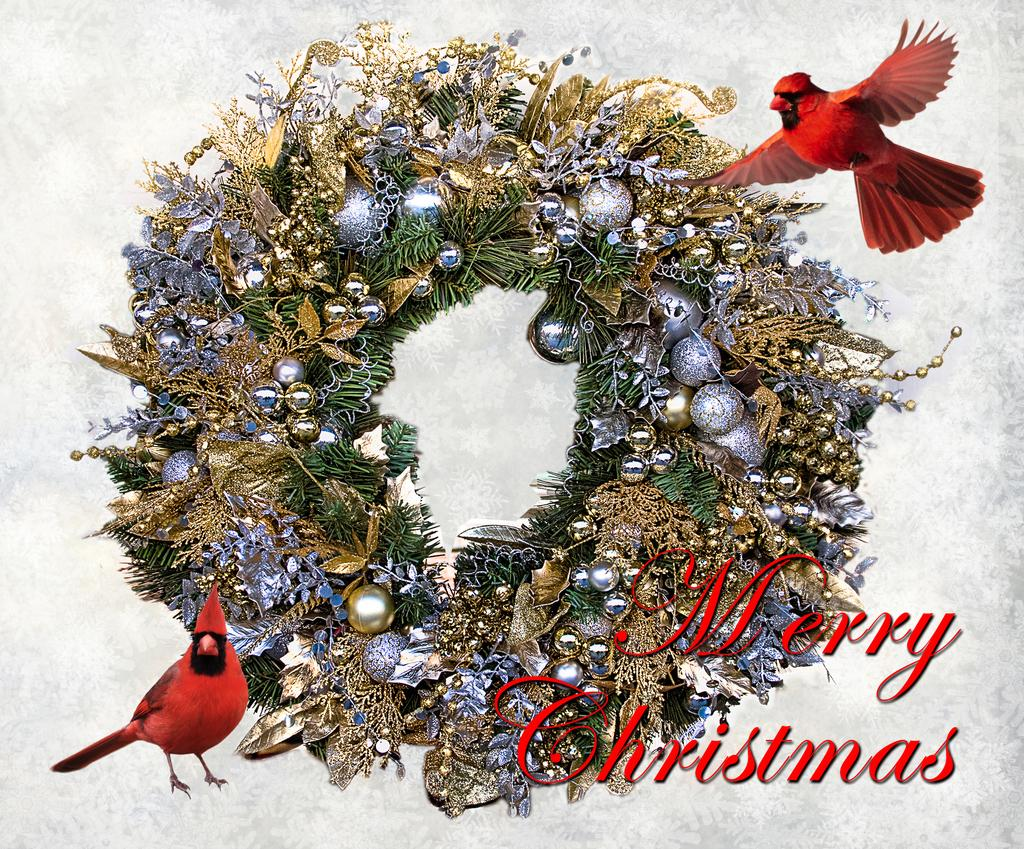How many red birds are in the image? There are two red birds in the image. What is one of the birds doing in the image? One of the birds is flying. What else can be seen in the image besides the birds? There are balls and leaves in the image. Are there any other objects present in the image? Yes, there are other objects present in the image. Where is the queen sitting at her desk along the coast in the image? There is no queen, desk, or coast present in the image. 